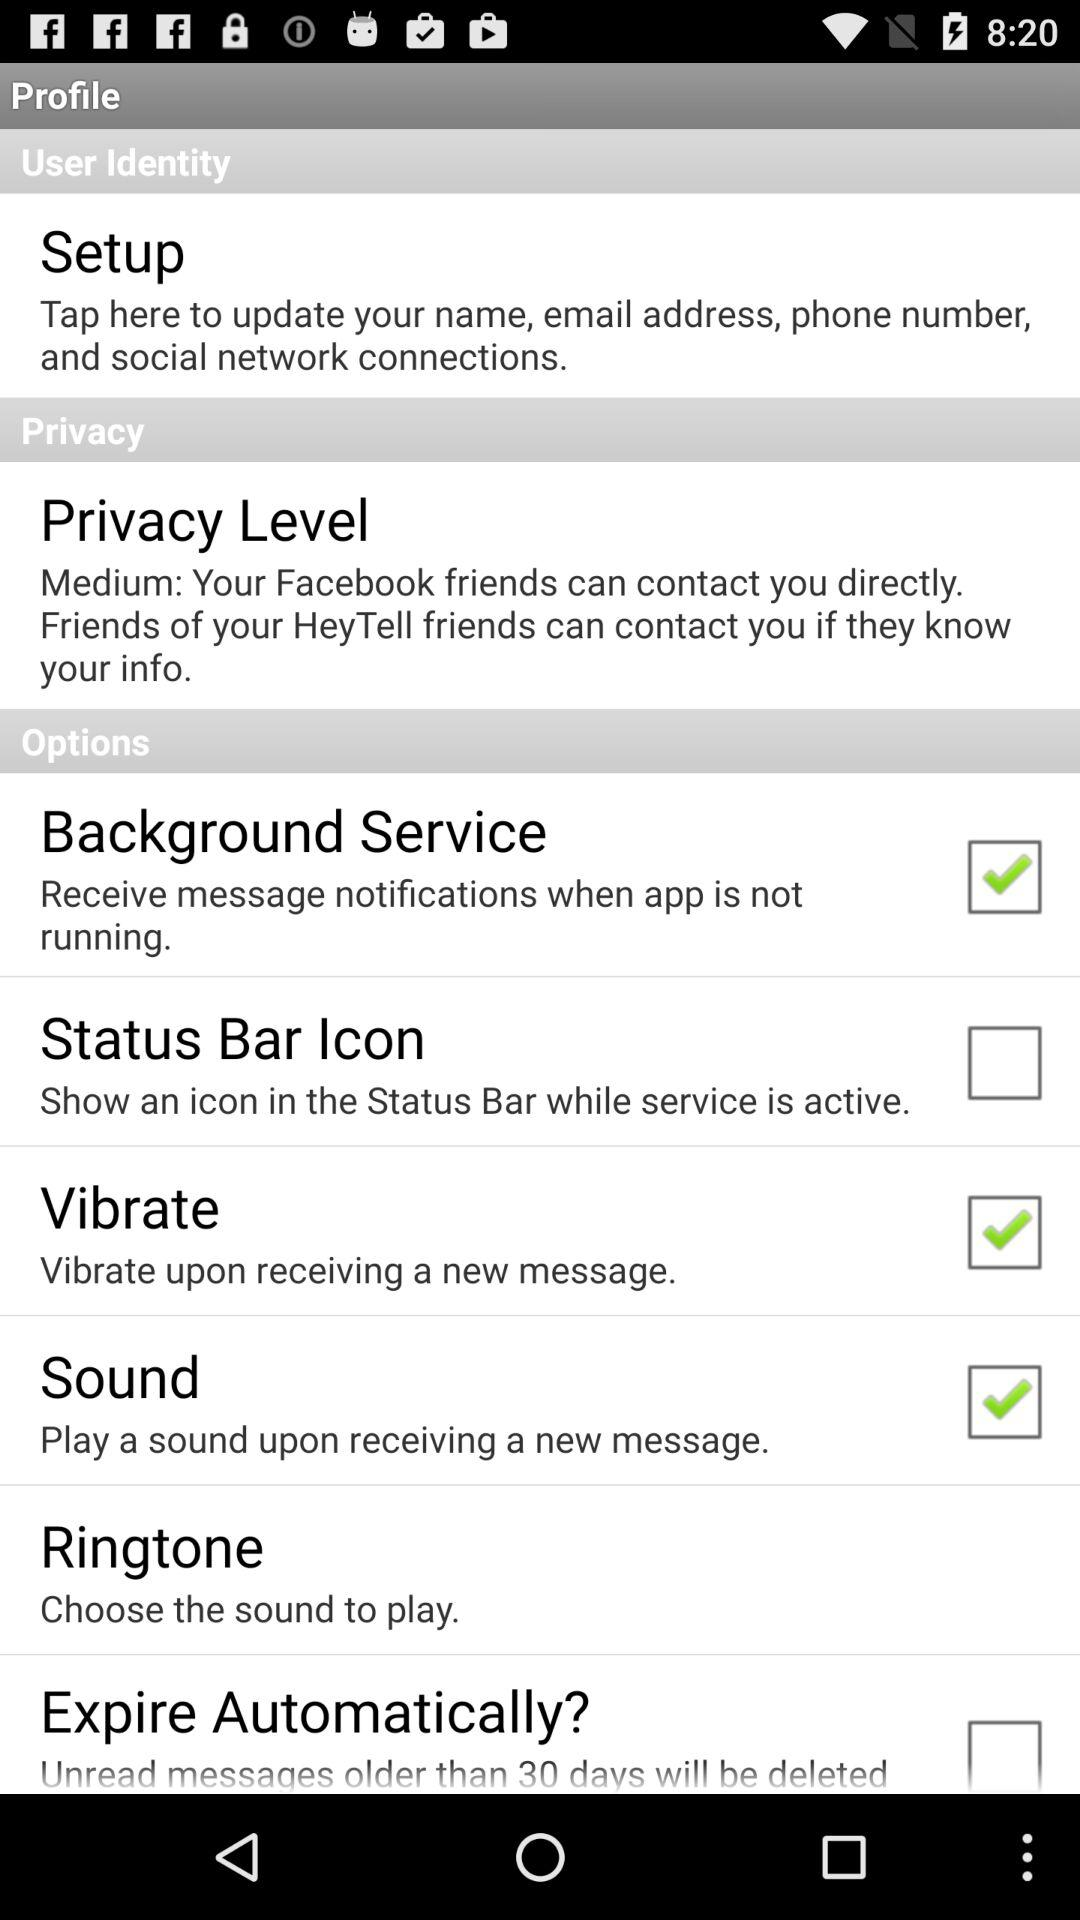What is the status of "Status Bar Icon"? The status is "off". 